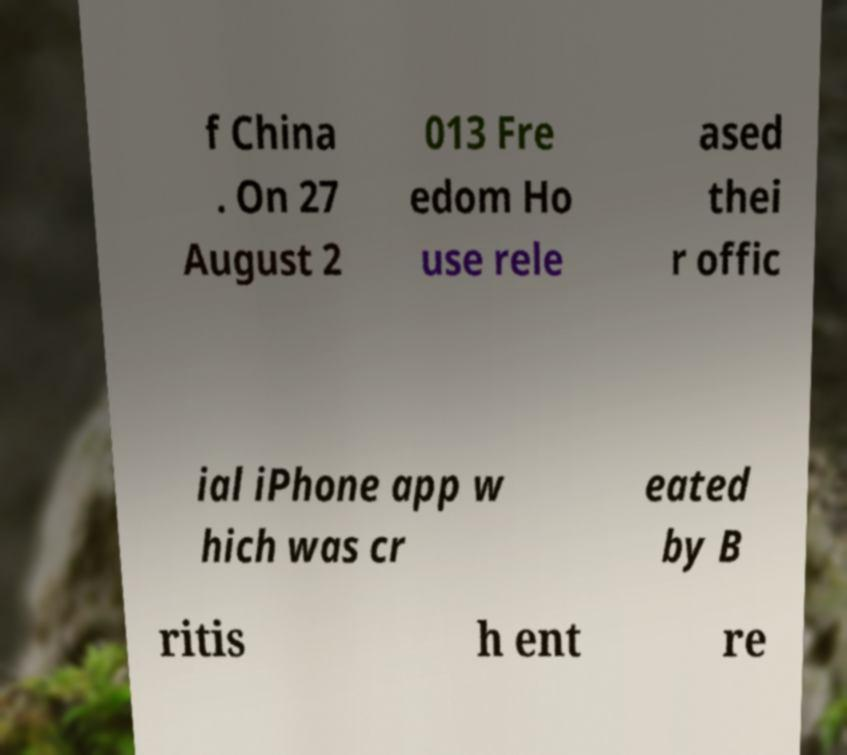Could you extract and type out the text from this image? f China . On 27 August 2 013 Fre edom Ho use rele ased thei r offic ial iPhone app w hich was cr eated by B ritis h ent re 